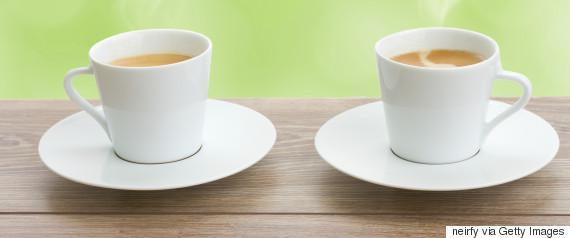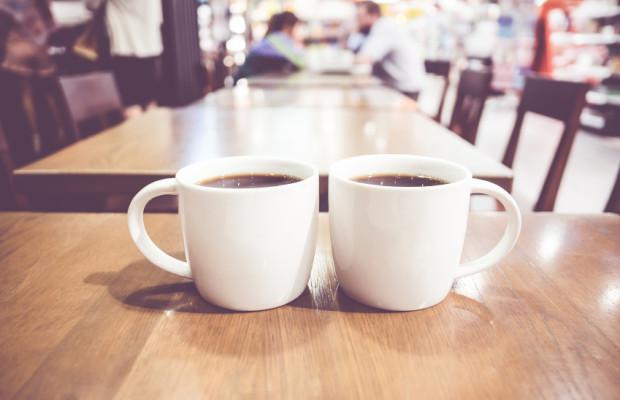The first image is the image on the left, the second image is the image on the right. Examine the images to the left and right. Is the description "An image shows exactly two side-by-side cups of beverages on saucers, without spoons." accurate? Answer yes or no. Yes. The first image is the image on the left, the second image is the image on the right. Analyze the images presented: Is the assertion "The two white cups in the image on the left are sitting in saucers." valid? Answer yes or no. Yes. 